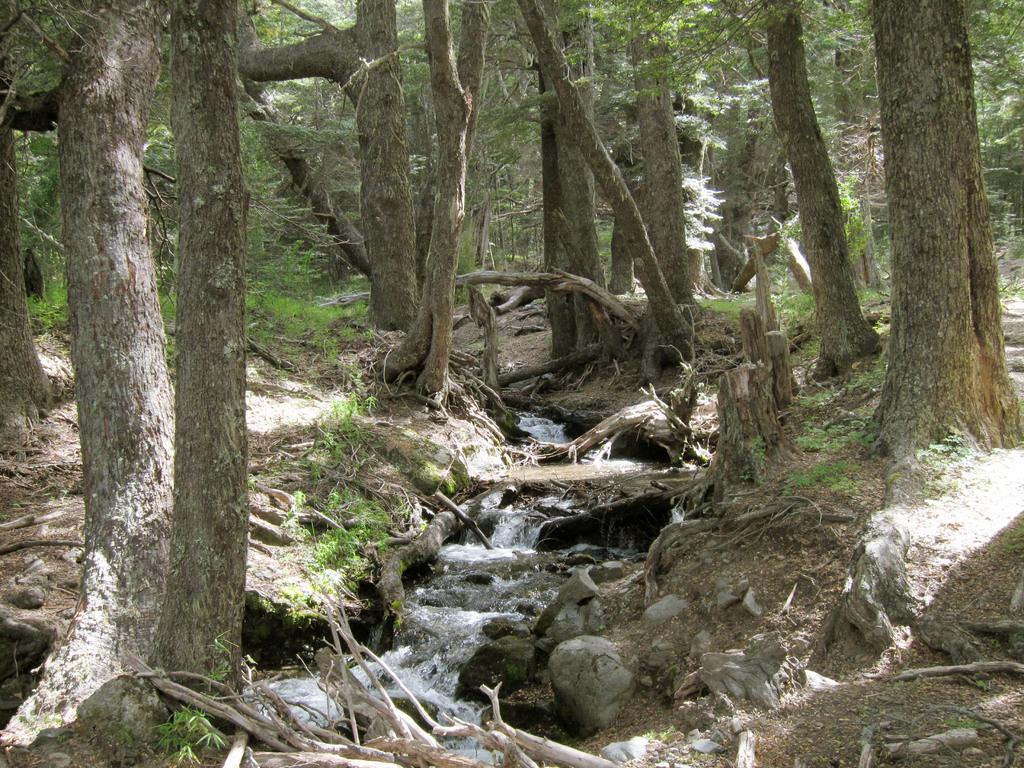What is the main feature of the image? The main feature of the image is a water flow. What can be seen on either side of the water flow? There are trees on either side of the water flow. What type of rest can be seen in the image? There is no rest visible in the image; it features a water flow with trees on either side. What do the trees in the image believe? Trees do not have the ability to believe, so this question cannot be answered. 